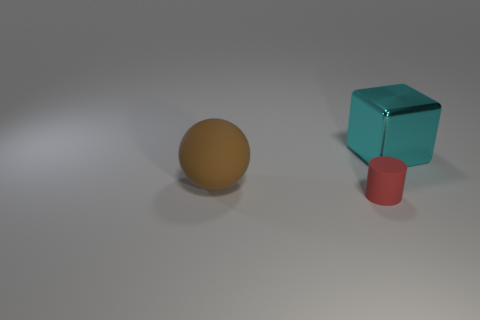Add 2 small gray matte spheres. How many objects exist? 5 Subtract all blocks. How many objects are left? 2 Subtract 1 blocks. How many blocks are left? 0 Subtract all blue cylinders. Subtract all purple spheres. How many cylinders are left? 1 Subtract all red blocks. How many blue cylinders are left? 0 Subtract all red objects. Subtract all tiny red objects. How many objects are left? 1 Add 2 big matte balls. How many big matte balls are left? 3 Add 2 large purple shiny blocks. How many large purple shiny blocks exist? 2 Subtract 0 purple cylinders. How many objects are left? 3 